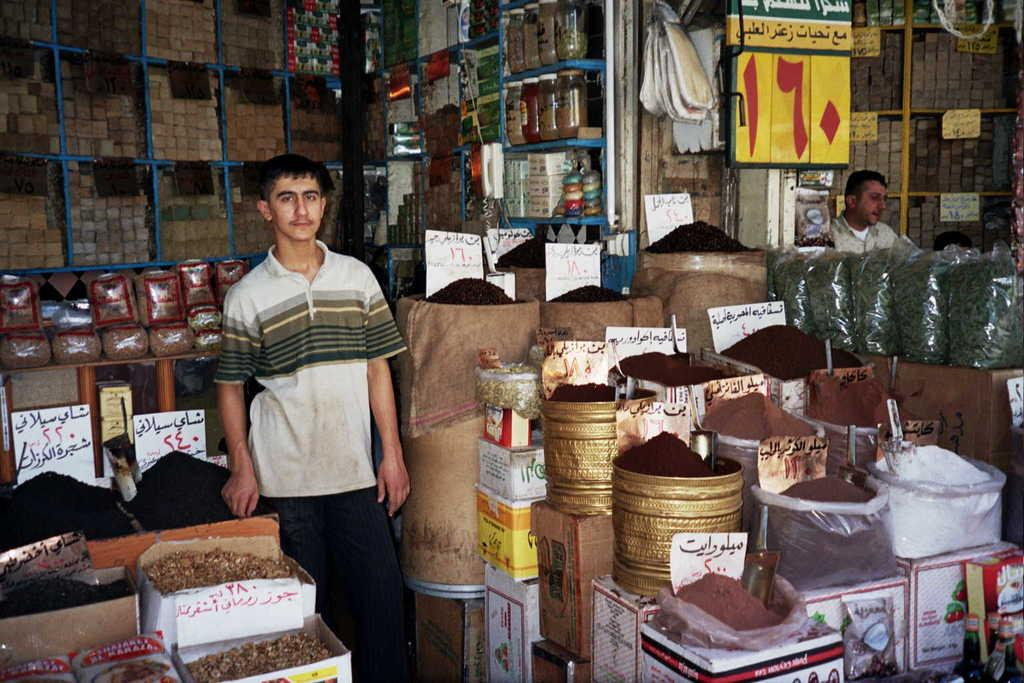What is the main subject of the image? The main subject of the image is a man standing in the shop. What can be seen in the shop besides the man standing? There are many powders and boxes in the shop. Are there any other people in the image? Yes, there is another man sitting on the right side. What type of animals can be seen in the zoo in the image? There is no zoo present in the image; it features a man standing in a shop with powders and boxes. What kind of music is the band playing in the background of the image? There is no band present in the image; it features a man standing in a shop with powders and boxes. 